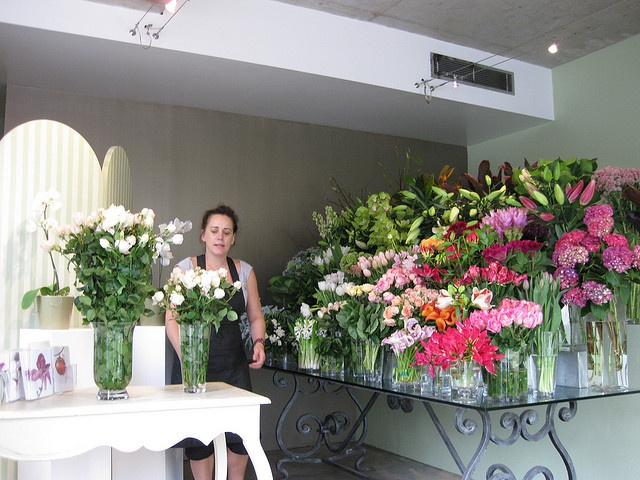Describe the objects in this image and their specific colors. I can see people in lavender, black, gray, and lightpink tones, potted plant in lavender, darkgreen, white, and green tones, potted plant in lavender, white, darkgreen, black, and green tones, potted plant in lavender, black, gray, and darkgreen tones, and potted plant in lavender, teal, lightpink, and green tones in this image. 